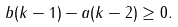Convert formula to latex. <formula><loc_0><loc_0><loc_500><loc_500>b ( k - 1 ) - a ( k - 2 ) \geq 0 .</formula> 